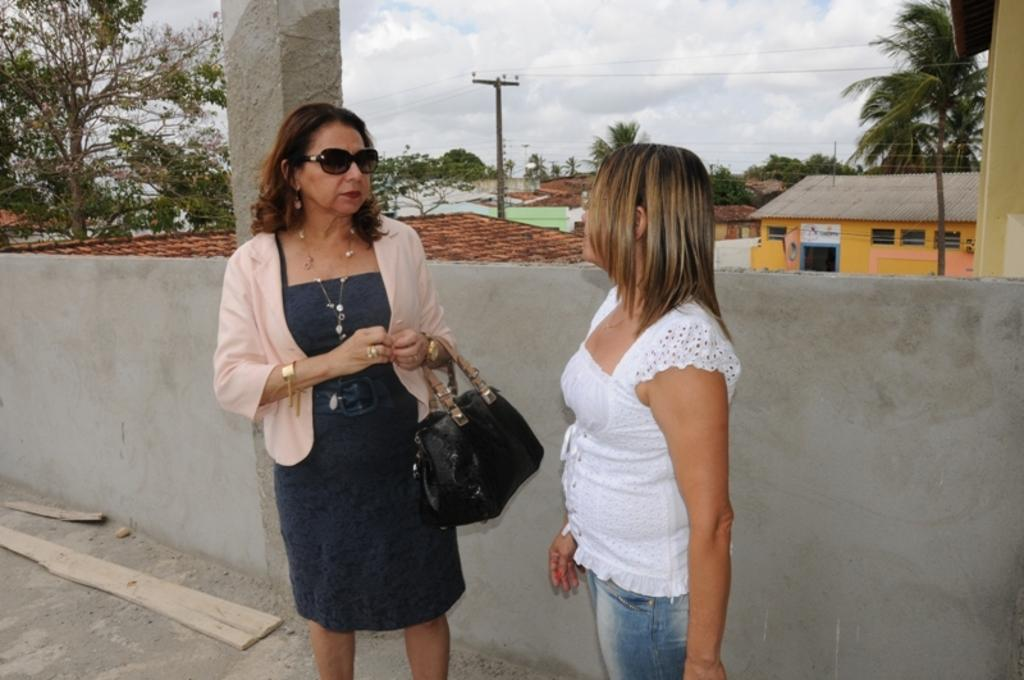How many people are in the image? There are two people in the image. What are the two people doing in the image? The two people are looking at each other. What is the woman in the image wearing? The woman in the image is wearing goggles. What is the woman in the image carrying? The woman in the image is carrying a bag. What can be seen in the background of the image? There are trees, houses with windows, and a current pole with cables in the background of the image. What is the condition of the sky in the image? The sky is cloudy in the image. What type of lace can be seen on the woman's dress in the image? There is no mention of a dress in the image, and the woman is not wearing lace. 